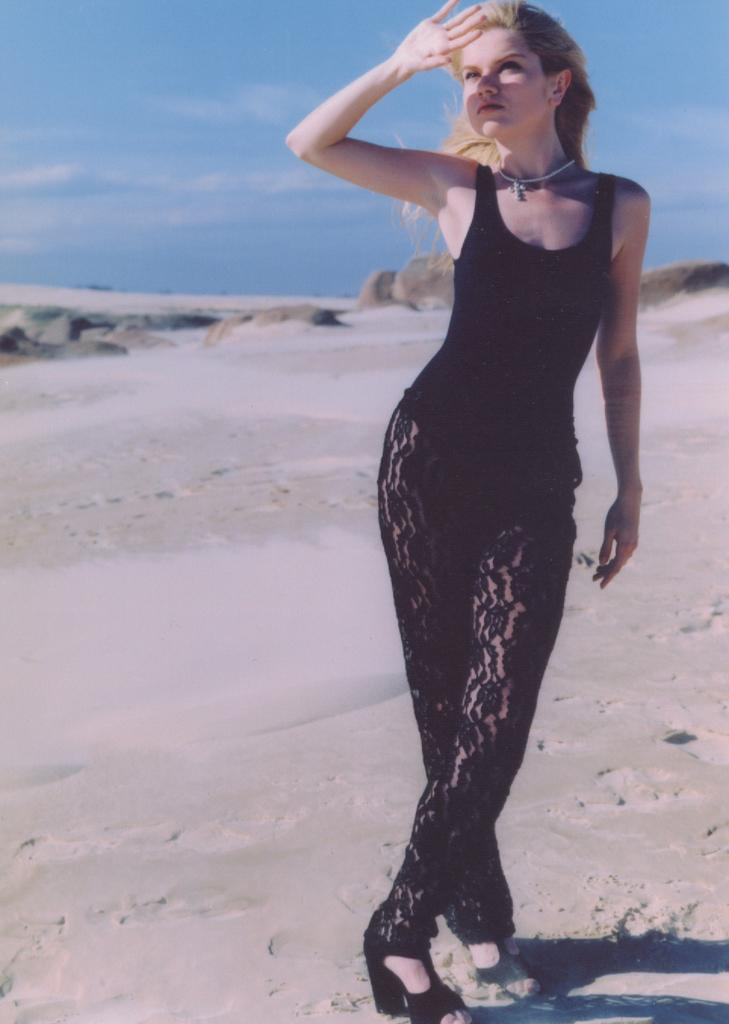Who is the main subject in the image? There is a lady in the image. What is the lady wearing? The lady is wearing a black dress. Where is the lady standing? The lady is standing on the ground. What can be seen in the background of the image? The sky is visible in the image. How many chairs are visible in the image? There are no chairs present in the image. What type of coat is the lady wearing in the image? The lady is not wearing a coat in the image; she is wearing a black dress. 